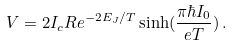<formula> <loc_0><loc_0><loc_500><loc_500>V = 2 I _ { c } R e ^ { - 2 E _ { J } / T } \sinh ( \frac { \pi \hbar { I } _ { 0 } } { e T } ) \, .</formula> 